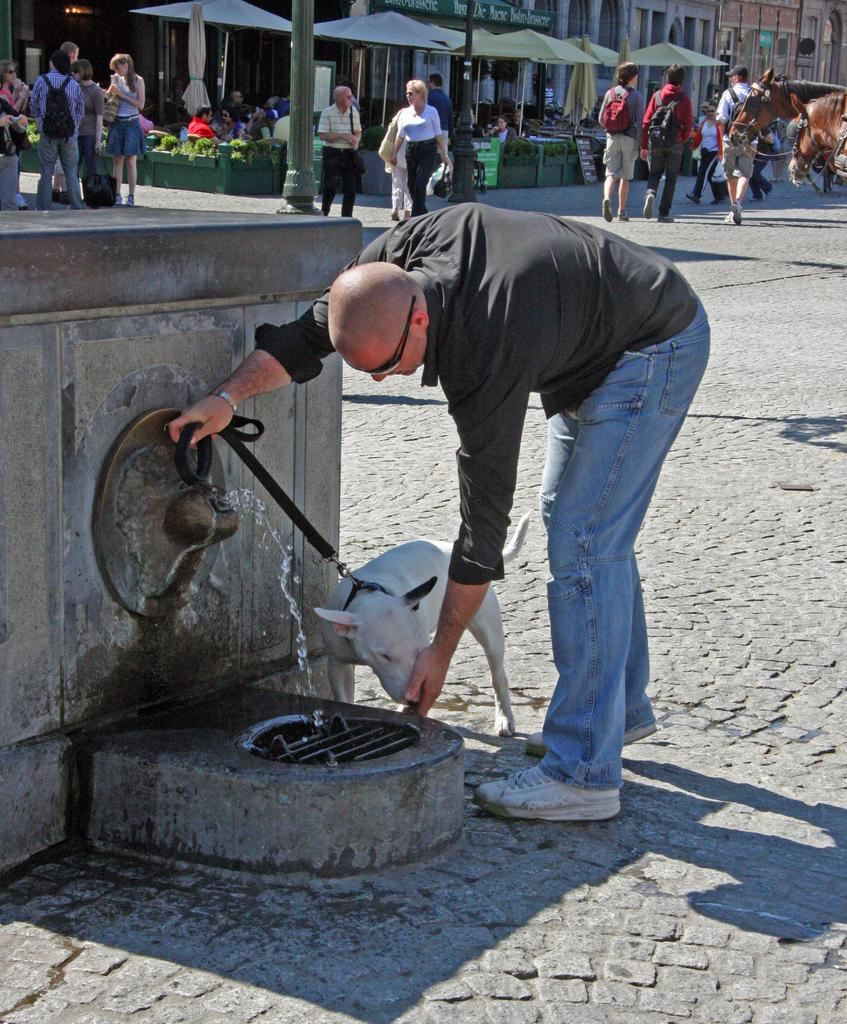Who is present in the image? There is a man in the image. What is the man holding in the image? The man is holding a dog. What can be seen at the bottom of the image? There is a road at the bottom of the image. What is happening in the background of the image? There are people walking in the background of the image, and there are stalls along with the buildings. What song is the man singing to the dog in the image? There is no indication in the image that the man is singing a song to the dog. 